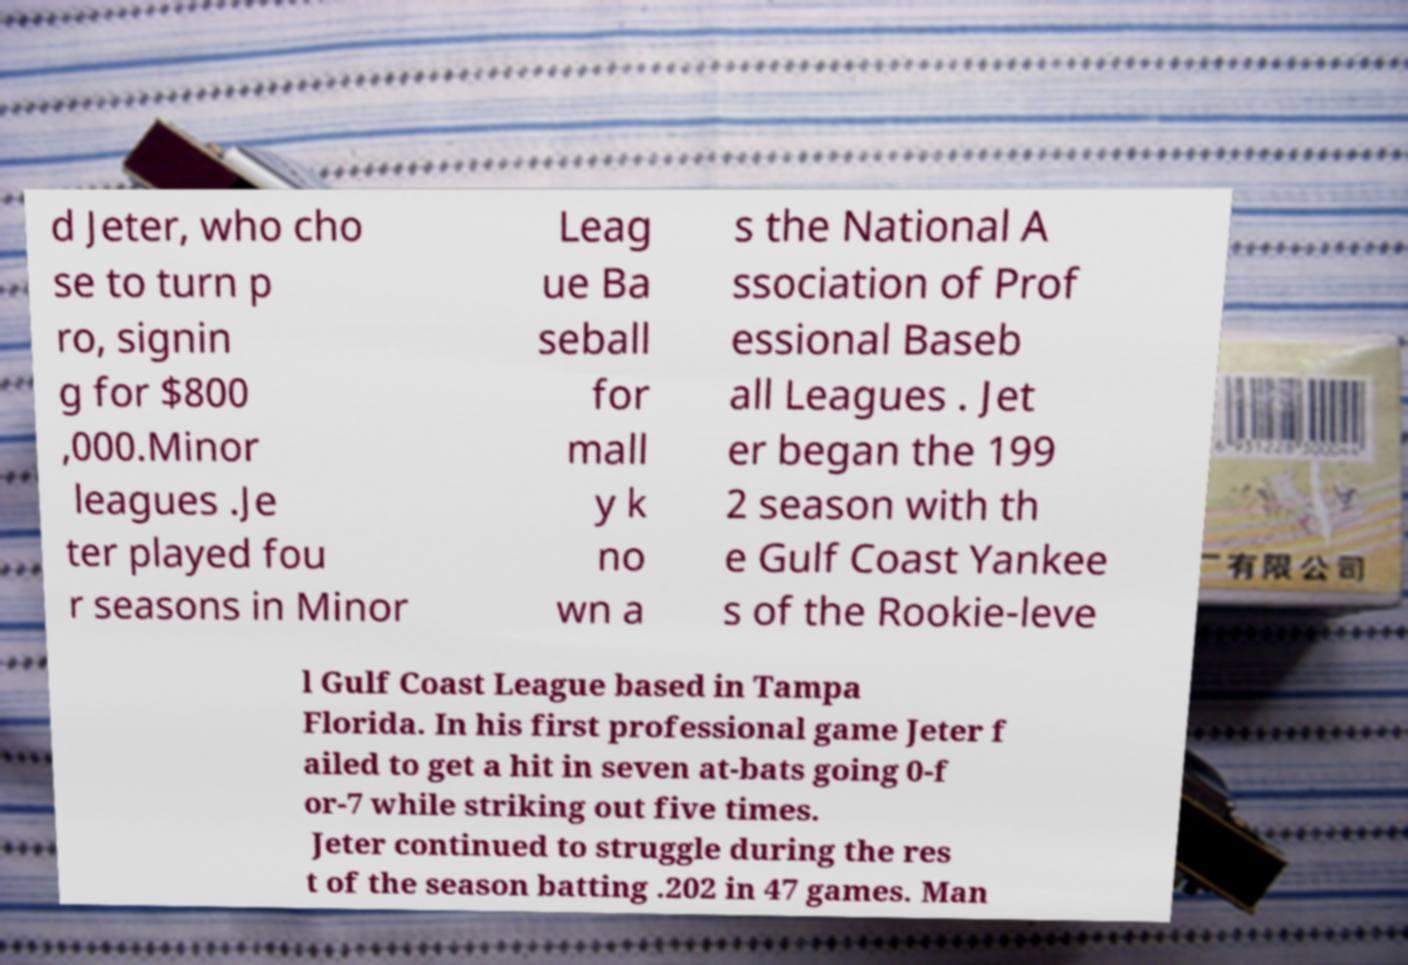Can you accurately transcribe the text from the provided image for me? d Jeter, who cho se to turn p ro, signin g for $800 ,000.Minor leagues .Je ter played fou r seasons in Minor Leag ue Ba seball for mall y k no wn a s the National A ssociation of Prof essional Baseb all Leagues . Jet er began the 199 2 season with th e Gulf Coast Yankee s of the Rookie-leve l Gulf Coast League based in Tampa Florida. In his first professional game Jeter f ailed to get a hit in seven at-bats going 0-f or-7 while striking out five times. Jeter continued to struggle during the res t of the season batting .202 in 47 games. Man 